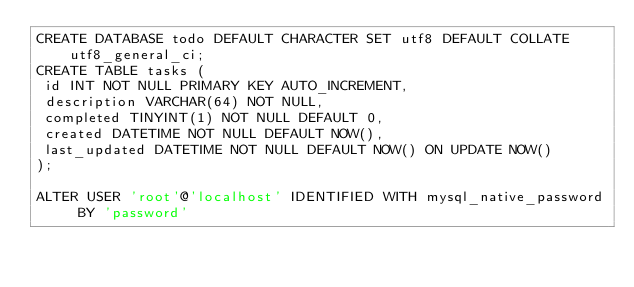<code> <loc_0><loc_0><loc_500><loc_500><_SQL_>CREATE DATABASE todo DEFAULT CHARACTER SET utf8 DEFAULT COLLATE utf8_general_ci;
CREATE TABLE tasks (
 id INT NOT NULL PRIMARY KEY AUTO_INCREMENT,
 description VARCHAR(64) NOT NULL,
 completed TINYINT(1) NOT NULL DEFAULT 0,
 created DATETIME NOT NULL DEFAULT NOW(),
 last_updated DATETIME NOT NULL DEFAULT NOW() ON UPDATE NOW()
);

ALTER USER 'root'@'localhost' IDENTIFIED WITH mysql_native_password BY 'password'</code> 